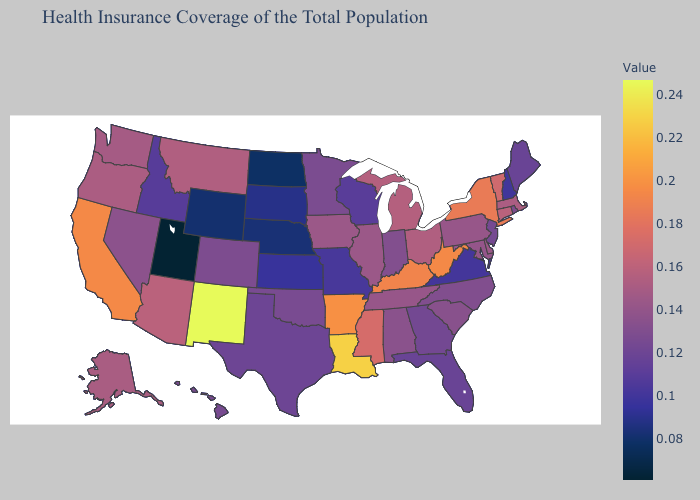Among the states that border Iowa , which have the lowest value?
Concise answer only. Nebraska. Is the legend a continuous bar?
Short answer required. Yes. Does Kansas have a higher value than Utah?
Concise answer only. Yes. Which states hav the highest value in the MidWest?
Answer briefly. Michigan. Among the states that border California , which have the lowest value?
Concise answer only. Nevada. 